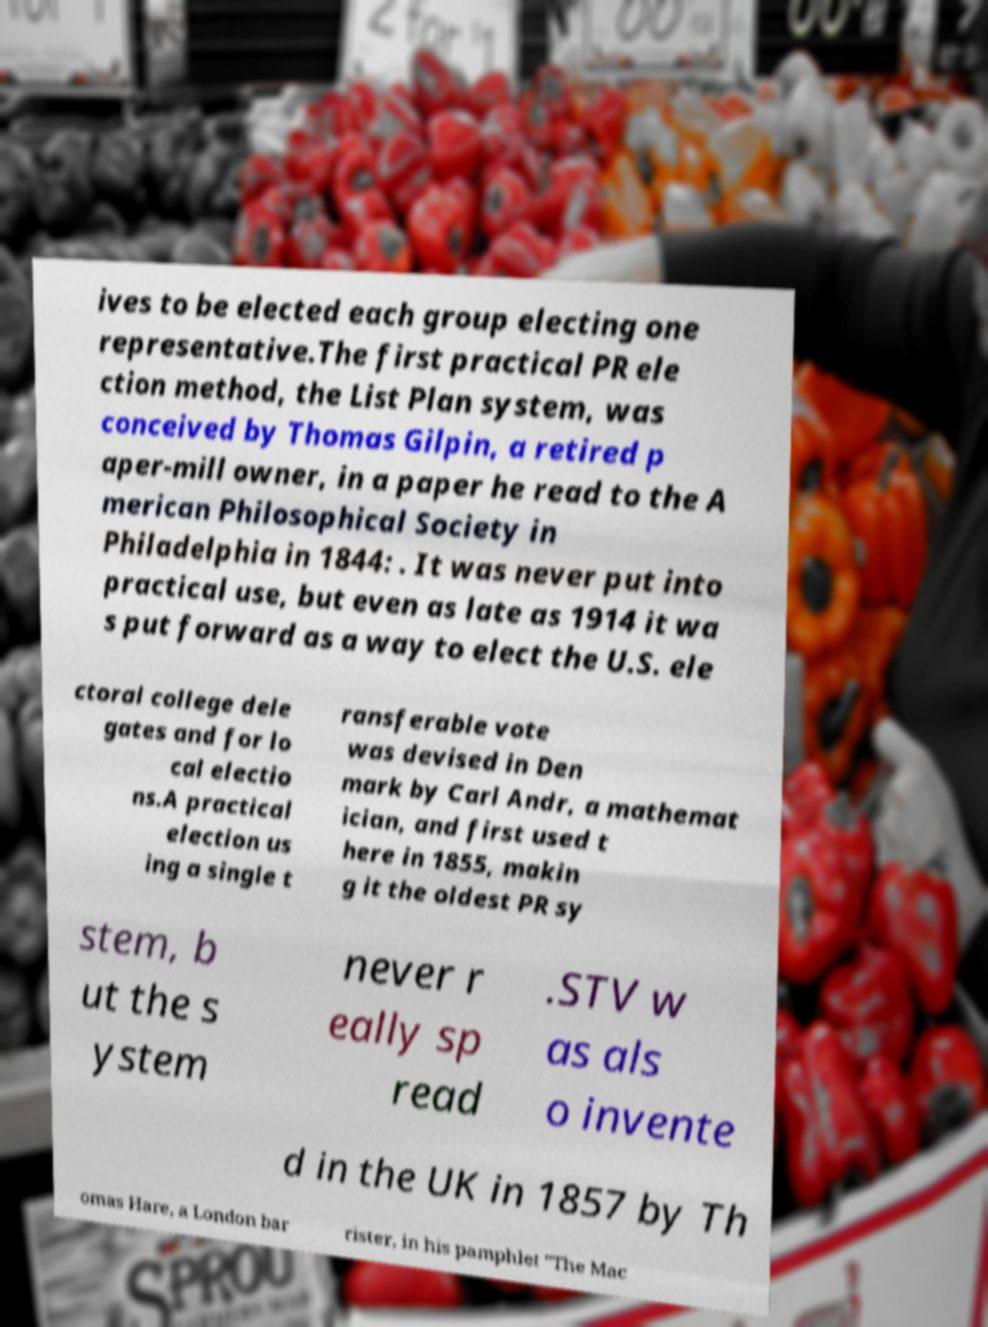For documentation purposes, I need the text within this image transcribed. Could you provide that? ives to be elected each group electing one representative.The first practical PR ele ction method, the List Plan system, was conceived by Thomas Gilpin, a retired p aper-mill owner, in a paper he read to the A merican Philosophical Society in Philadelphia in 1844: . It was never put into practical use, but even as late as 1914 it wa s put forward as a way to elect the U.S. ele ctoral college dele gates and for lo cal electio ns.A practical election us ing a single t ransferable vote was devised in Den mark by Carl Andr, a mathemat ician, and first used t here in 1855, makin g it the oldest PR sy stem, b ut the s ystem never r eally sp read .STV w as als o invente d in the UK in 1857 by Th omas Hare, a London bar rister, in his pamphlet "The Mac 